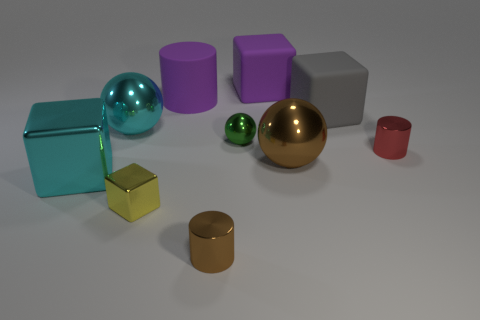What might be the relative sizes of the purple and silver cubes? The purple cubes appear larger than the silver cube. The front purple cube has dimensions larger than those of the silver cube, and the other purple cube, even though it's partially obscured, seems to match the size of its sibling, indicating they are larger compared to the silver cube. 